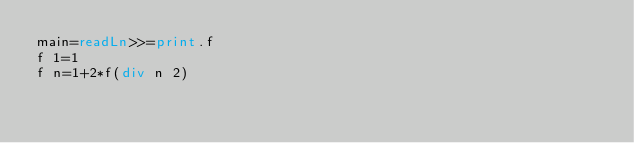Convert code to text. <code><loc_0><loc_0><loc_500><loc_500><_Haskell_>main=readLn>>=print.f
f 1=1
f n=1+2*f(div n 2)</code> 